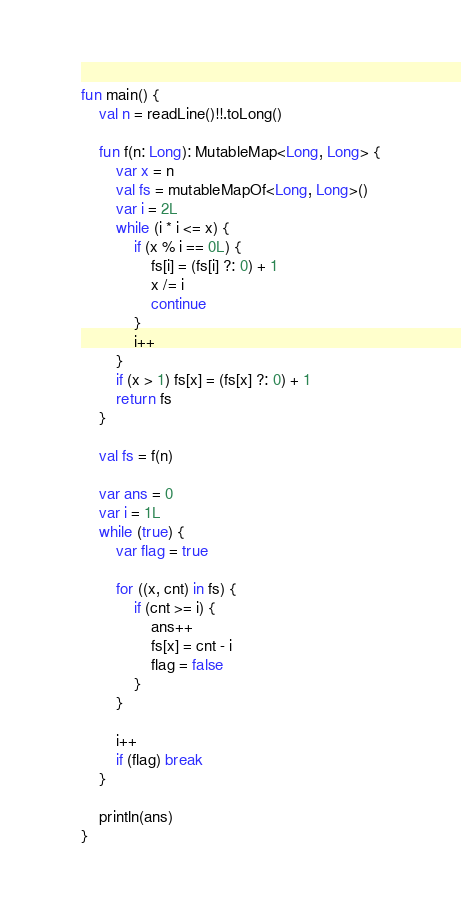Convert code to text. <code><loc_0><loc_0><loc_500><loc_500><_Kotlin_>fun main() {
    val n = readLine()!!.toLong()

    fun f(n: Long): MutableMap<Long, Long> {
        var x = n
        val fs = mutableMapOf<Long, Long>()
        var i = 2L
        while (i * i <= x) {
            if (x % i == 0L) {
                fs[i] = (fs[i] ?: 0) + 1
                x /= i
                continue
            }
            i++
        }
        if (x > 1) fs[x] = (fs[x] ?: 0) + 1
        return fs
    }

    val fs = f(n)

    var ans = 0
    var i = 1L
    while (true) {
        var flag = true

        for ((x, cnt) in fs) {
            if (cnt >= i) {
                ans++
                fs[x] = cnt - i
                flag = false
            }
        }

        i++
        if (flag) break
    }

    println(ans)
}
</code> 